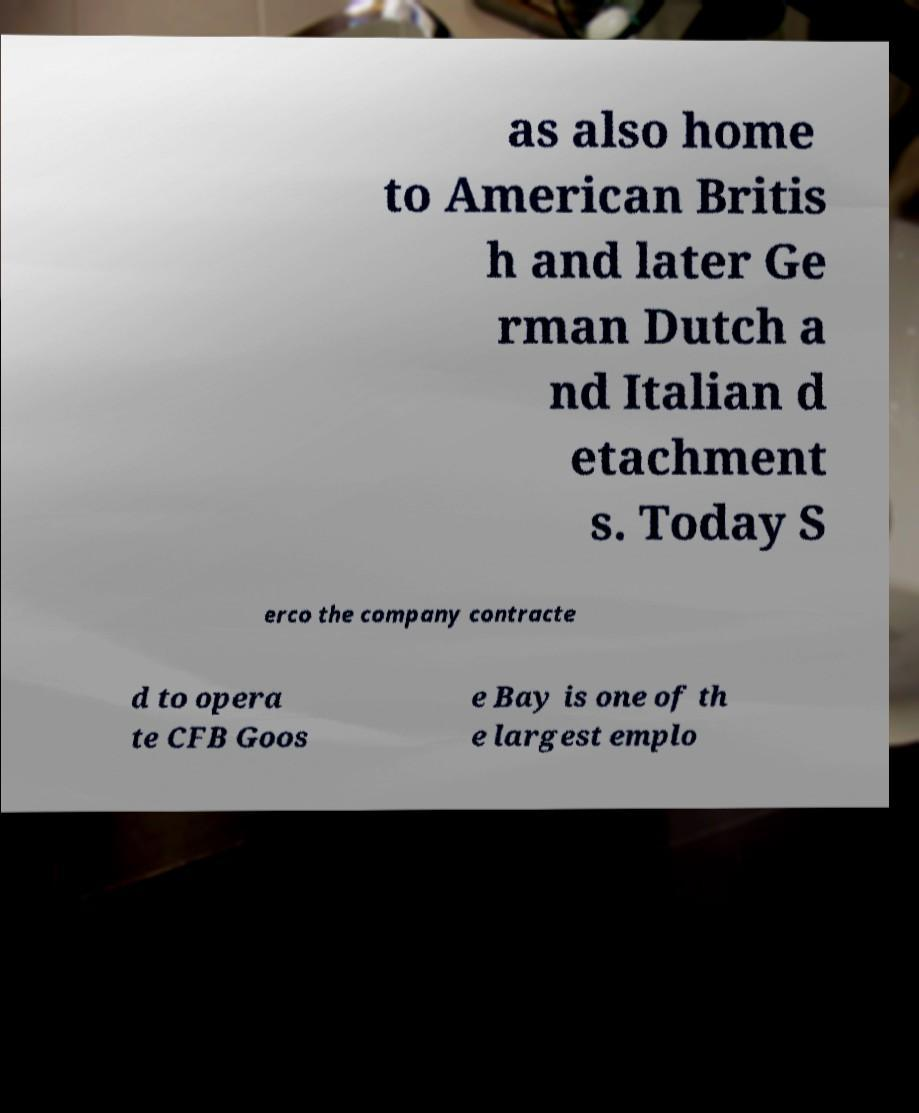Can you accurately transcribe the text from the provided image for me? as also home to American Britis h and later Ge rman Dutch a nd Italian d etachment s. Today S erco the company contracte d to opera te CFB Goos e Bay is one of th e largest emplo 